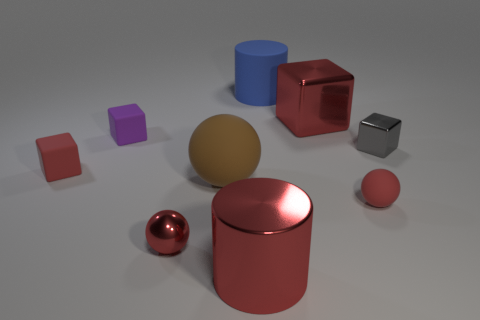Add 1 purple cubes. How many objects exist? 10 Subtract all small red balls. How many balls are left? 1 Subtract all red cylinders. How many cylinders are left? 1 Subtract all green cubes. How many red spheres are left? 2 Subtract 1 spheres. How many spheres are left? 2 Add 9 small cyan cubes. How many small cyan cubes exist? 9 Subtract 0 purple cylinders. How many objects are left? 9 Subtract all cylinders. How many objects are left? 7 Subtract all red balls. Subtract all cyan blocks. How many balls are left? 1 Subtract all big red shiny things. Subtract all big shiny cubes. How many objects are left? 6 